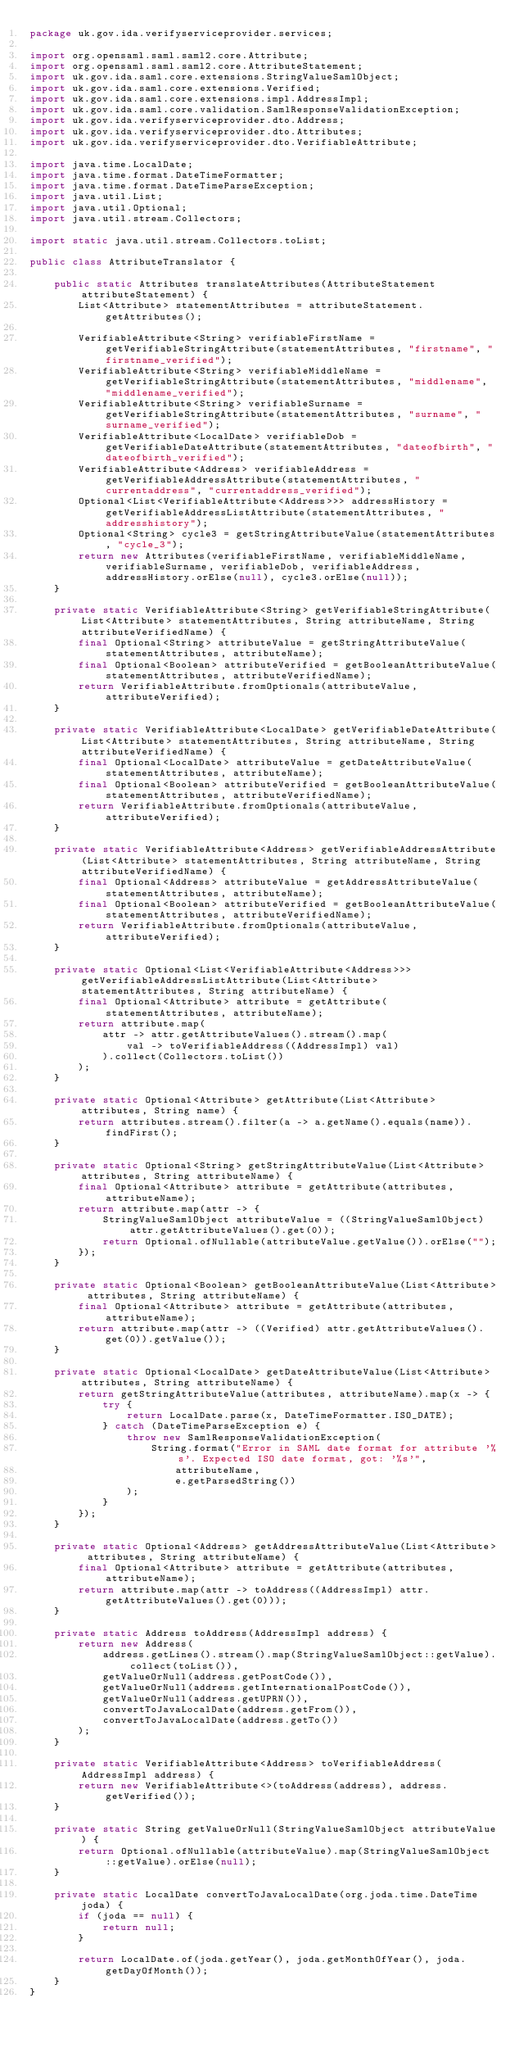Convert code to text. <code><loc_0><loc_0><loc_500><loc_500><_Java_>package uk.gov.ida.verifyserviceprovider.services;

import org.opensaml.saml.saml2.core.Attribute;
import org.opensaml.saml.saml2.core.AttributeStatement;
import uk.gov.ida.saml.core.extensions.StringValueSamlObject;
import uk.gov.ida.saml.core.extensions.Verified;
import uk.gov.ida.saml.core.extensions.impl.AddressImpl;
import uk.gov.ida.saml.core.validation.SamlResponseValidationException;
import uk.gov.ida.verifyserviceprovider.dto.Address;
import uk.gov.ida.verifyserviceprovider.dto.Attributes;
import uk.gov.ida.verifyserviceprovider.dto.VerifiableAttribute;

import java.time.LocalDate;
import java.time.format.DateTimeFormatter;
import java.time.format.DateTimeParseException;
import java.util.List;
import java.util.Optional;
import java.util.stream.Collectors;

import static java.util.stream.Collectors.toList;

public class AttributeTranslator {

    public static Attributes translateAttributes(AttributeStatement attributeStatement) {
        List<Attribute> statementAttributes = attributeStatement.getAttributes();

        VerifiableAttribute<String> verifiableFirstName = getVerifiableStringAttribute(statementAttributes, "firstname", "firstname_verified");
        VerifiableAttribute<String> verifiableMiddleName = getVerifiableStringAttribute(statementAttributes, "middlename", "middlename_verified");
        VerifiableAttribute<String> verifiableSurname = getVerifiableStringAttribute(statementAttributes, "surname", "surname_verified");
        VerifiableAttribute<LocalDate> verifiableDob = getVerifiableDateAttribute(statementAttributes, "dateofbirth", "dateofbirth_verified");
        VerifiableAttribute<Address> verifiableAddress = getVerifiableAddressAttribute(statementAttributes, "currentaddress", "currentaddress_verified");
        Optional<List<VerifiableAttribute<Address>>> addressHistory = getVerifiableAddressListAttribute(statementAttributes, "addresshistory");
        Optional<String> cycle3 = getStringAttributeValue(statementAttributes, "cycle_3");
        return new Attributes(verifiableFirstName, verifiableMiddleName, verifiableSurname, verifiableDob, verifiableAddress, addressHistory.orElse(null), cycle3.orElse(null));
    }

    private static VerifiableAttribute<String> getVerifiableStringAttribute(List<Attribute> statementAttributes, String attributeName, String attributeVerifiedName) {
        final Optional<String> attributeValue = getStringAttributeValue(statementAttributes, attributeName);
        final Optional<Boolean> attributeVerified = getBooleanAttributeValue(statementAttributes, attributeVerifiedName);
        return VerifiableAttribute.fromOptionals(attributeValue, attributeVerified);
    }

    private static VerifiableAttribute<LocalDate> getVerifiableDateAttribute(List<Attribute> statementAttributes, String attributeName, String attributeVerifiedName) {
        final Optional<LocalDate> attributeValue = getDateAttributeValue(statementAttributes, attributeName);
        final Optional<Boolean> attributeVerified = getBooleanAttributeValue(statementAttributes, attributeVerifiedName);
        return VerifiableAttribute.fromOptionals(attributeValue, attributeVerified);
    }

    private static VerifiableAttribute<Address> getVerifiableAddressAttribute(List<Attribute> statementAttributes, String attributeName, String attributeVerifiedName) {
        final Optional<Address> attributeValue = getAddressAttributeValue(statementAttributes, attributeName);
        final Optional<Boolean> attributeVerified = getBooleanAttributeValue(statementAttributes, attributeVerifiedName);
        return VerifiableAttribute.fromOptionals(attributeValue, attributeVerified);
    }

    private static Optional<List<VerifiableAttribute<Address>>> getVerifiableAddressListAttribute(List<Attribute> statementAttributes, String attributeName) {
        final Optional<Attribute> attribute = getAttribute(statementAttributes, attributeName);
        return attribute.map(
            attr -> attr.getAttributeValues().stream().map(
                val -> toVerifiableAddress((AddressImpl) val)
            ).collect(Collectors.toList())
        );
    }

    private static Optional<Attribute> getAttribute(List<Attribute> attributes, String name) {
        return attributes.stream().filter(a -> a.getName().equals(name)).findFirst();
    }

    private static Optional<String> getStringAttributeValue(List<Attribute> attributes, String attributeName) {
        final Optional<Attribute> attribute = getAttribute(attributes, attributeName);
        return attribute.map(attr -> {
            StringValueSamlObject attributeValue = ((StringValueSamlObject) attr.getAttributeValues().get(0));
            return Optional.ofNullable(attributeValue.getValue()).orElse("");
        });
    }

    private static Optional<Boolean> getBooleanAttributeValue(List<Attribute> attributes, String attributeName) {
        final Optional<Attribute> attribute = getAttribute(attributes, attributeName);
        return attribute.map(attr -> ((Verified) attr.getAttributeValues().get(0)).getValue());
    }

    private static Optional<LocalDate> getDateAttributeValue(List<Attribute> attributes, String attributeName) {
        return getStringAttributeValue(attributes, attributeName).map(x -> {
            try {
                return LocalDate.parse(x, DateTimeFormatter.ISO_DATE);
            } catch (DateTimeParseException e) {
                throw new SamlResponseValidationException(
                    String.format("Error in SAML date format for attribute '%s'. Expected ISO date format, got: '%s'",
                        attributeName,
                        e.getParsedString())
                );
            }
        });
    }

    private static Optional<Address> getAddressAttributeValue(List<Attribute> attributes, String attributeName) {
        final Optional<Attribute> attribute = getAttribute(attributes, attributeName);
        return attribute.map(attr -> toAddress((AddressImpl) attr.getAttributeValues().get(0)));
    }

    private static Address toAddress(AddressImpl address) {
        return new Address(
            address.getLines().stream().map(StringValueSamlObject::getValue).collect(toList()),
            getValueOrNull(address.getPostCode()),
            getValueOrNull(address.getInternationalPostCode()),
            getValueOrNull(address.getUPRN()),
            convertToJavaLocalDate(address.getFrom()),
            convertToJavaLocalDate(address.getTo())
        );
    }

    private static VerifiableAttribute<Address> toVerifiableAddress(AddressImpl address) {
        return new VerifiableAttribute<>(toAddress(address), address.getVerified());
    }

    private static String getValueOrNull(StringValueSamlObject attributeValue) {
        return Optional.ofNullable(attributeValue).map(StringValueSamlObject::getValue).orElse(null);
    }

    private static LocalDate convertToJavaLocalDate(org.joda.time.DateTime joda) {
        if (joda == null) {
            return null;
        }

        return LocalDate.of(joda.getYear(), joda.getMonthOfYear(), joda.getDayOfMonth());
    }
}
</code> 